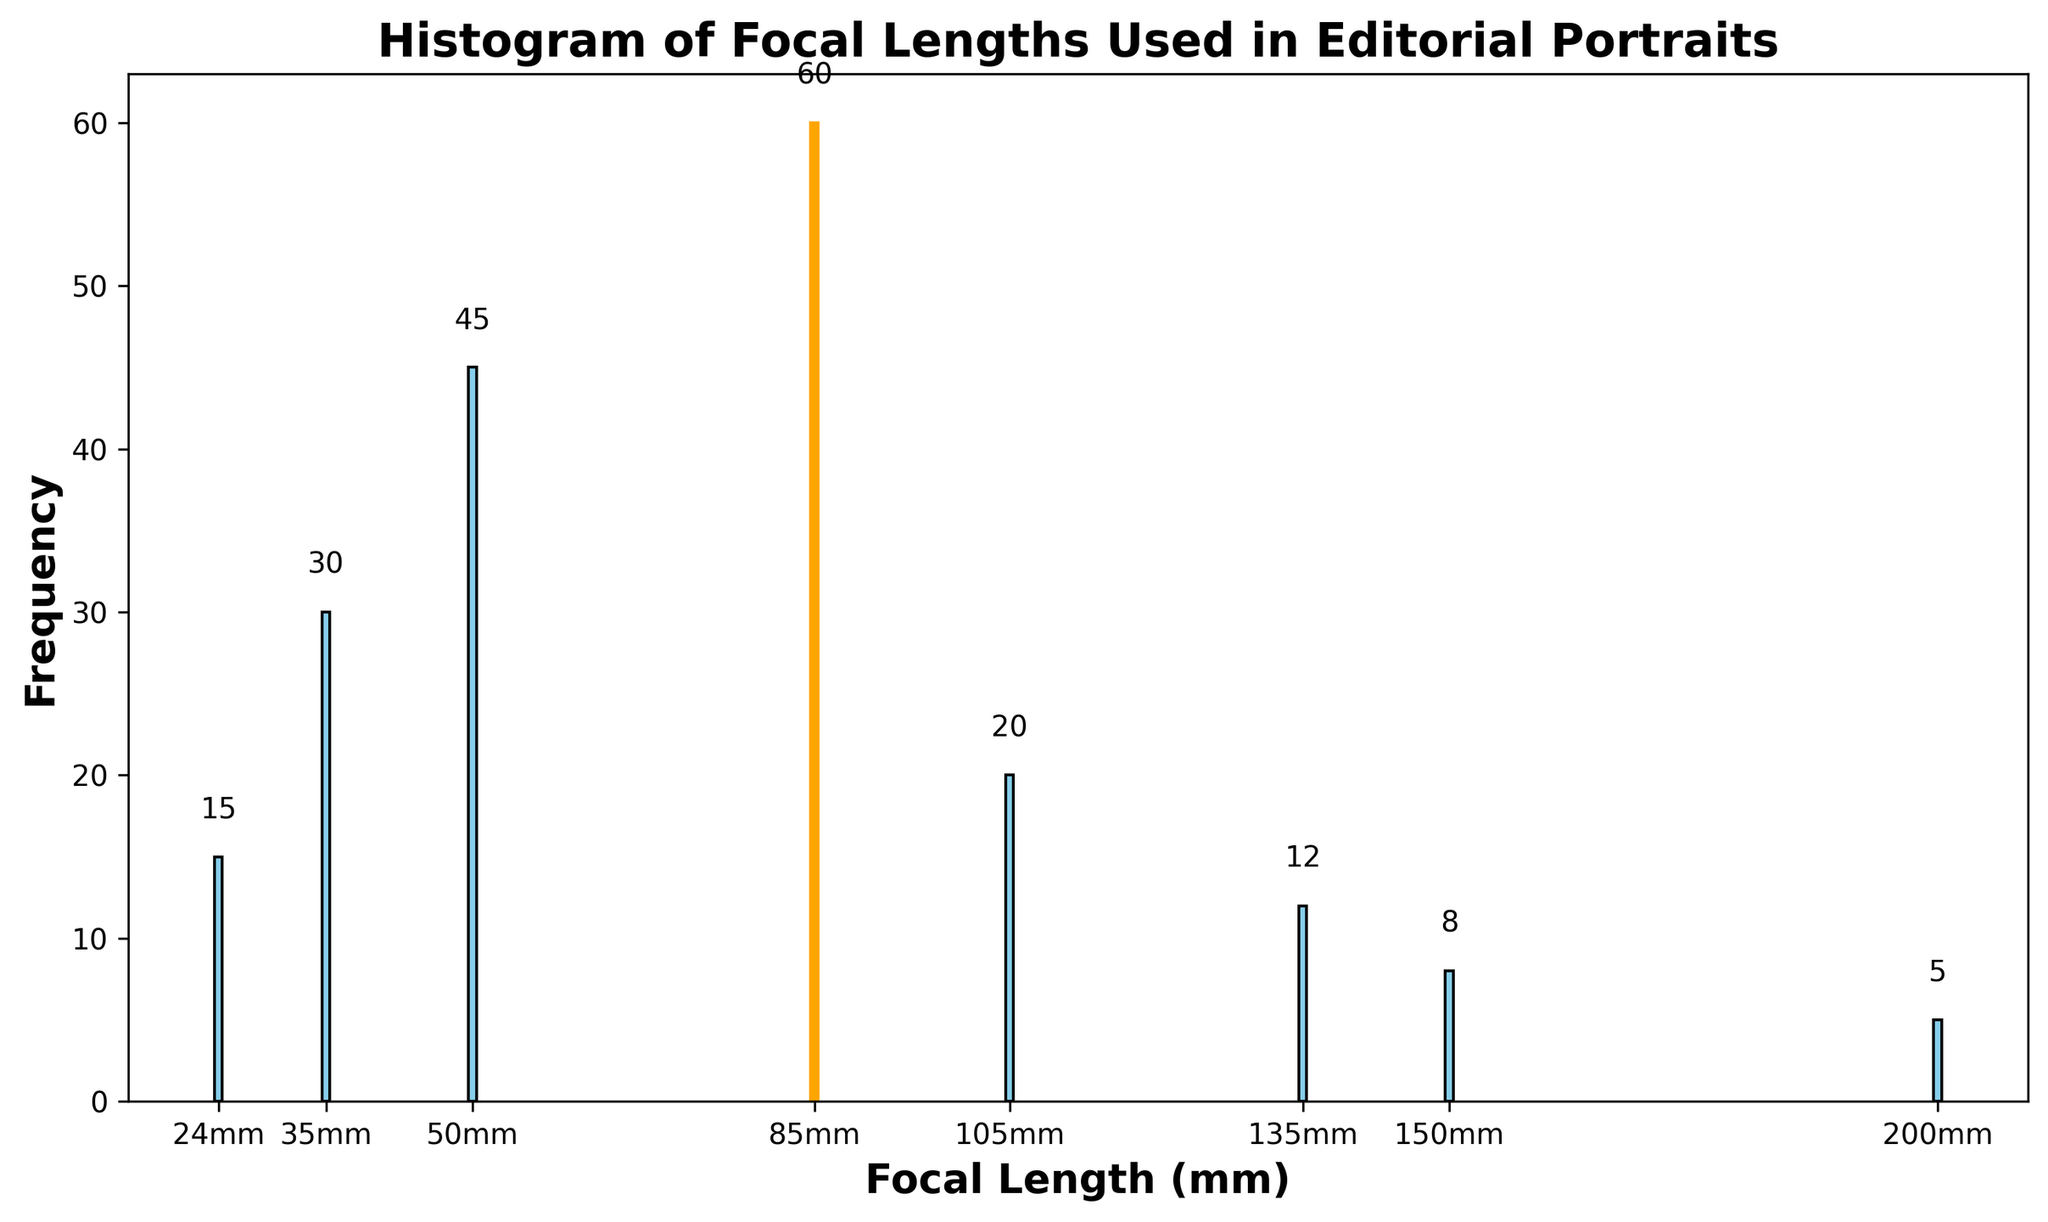What focal length is used the most frequently? The tallest bar in the histogram is at the focal length of 85mm. The color of this bar is highlighted in orange. Hence, 85mm is the focal length used most frequently.
Answer: 85mm What is the combined frequency of the least used focal lengths, 200mm and 150mm? The frequencies of 200mm and 150mm bars are 5 and 8 respectively. Adding these values gives 5 + 8 = 13.
Answer: 13 How much more frequently is 85mm used compared to 35mm? The bar for 85mm has a frequency of 60, and the bar for 35mm has a frequency of 30. The difference is 60 - 30 = 30.
Answer: 30 Which focal length greater than 100mm has the highest frequency? The focal lengths greater than 100mm in the figure are 105mm, 135mm, 150mm, and 200mm. Among these, the 105mm bar is the tallest with a frequency of 20.
Answer: 105mm How does the frequency of 24mm compare to 135mm? The 24mm bar has a frequency of 15 while the 135mm bar has a frequency of 12. Thus, 24mm is used more frequently than 135mm by 3.
Answer: 3 What is the total frequency of all the focal lengths used? Add the frequencies of all focal lengths: 15 (24mm) + 30 (35mm) + 45 (50mm) + 60 (85mm) + 20 (105mm) + 12 (135mm) + 8 (150mm) + 5 (200mm) = 195.
Answer: 195 What is the average frequency of the focal lengths used? The total frequency is 195, and there are 8 focal lengths. Divide the total frequency by the number of focal lengths: 195 / 8 = 24.375.
Answer: 24.375 Which focal lengths have a frequency lower than 20? The focal lengths with frequencies lower than 20 are 24mm (15), 135mm (12), 150mm (8), and 200mm (5).
Answer: 24mm, 135mm, 150mm, 200mm What is the median frequency of the focal lengths used? Arrange the frequencies in ascending order: 5, 8, 12, 15, 20, 30, 45, 60. The median of an even set is the average of the middle two numbers: (15 + 20) / 2 = 17.5.
Answer: 17.5 